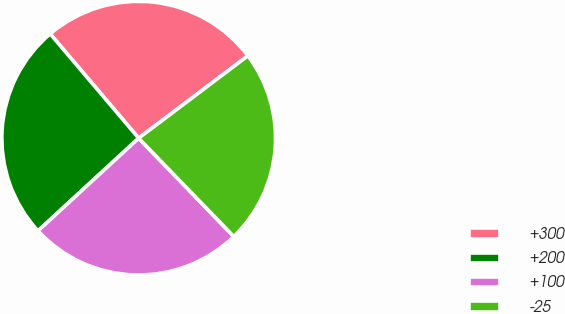<chart> <loc_0><loc_0><loc_500><loc_500><pie_chart><fcel>+300<fcel>+200<fcel>+100<fcel>-25<nl><fcel>25.91%<fcel>25.65%<fcel>25.39%<fcel>23.05%<nl></chart> 